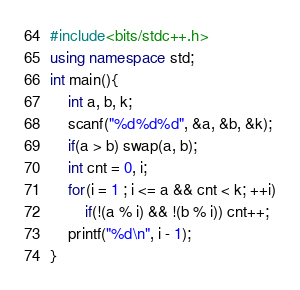<code> <loc_0><loc_0><loc_500><loc_500><_C++_>#include<bits/stdc++.h>
using namespace std;
int main(){
	int a, b, k;
  	scanf("%d%d%d", &a, &b, &k);
  	if(a > b) swap(a, b);
  	int cnt = 0, i;
  	for(i = 1 ; i <= a && cnt < k; ++i)
    	if(!(a % i) && !(b % i)) cnt++;
  	printf("%d\n", i - 1);
}</code> 